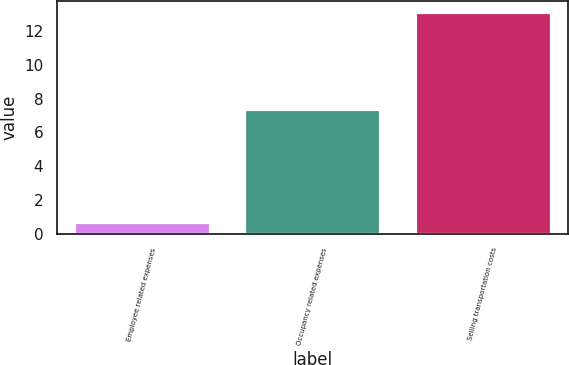<chart> <loc_0><loc_0><loc_500><loc_500><bar_chart><fcel>Employee related expenses<fcel>Occupancy related expenses<fcel>Selling transportation costs<nl><fcel>0.7<fcel>7.4<fcel>13.1<nl></chart> 